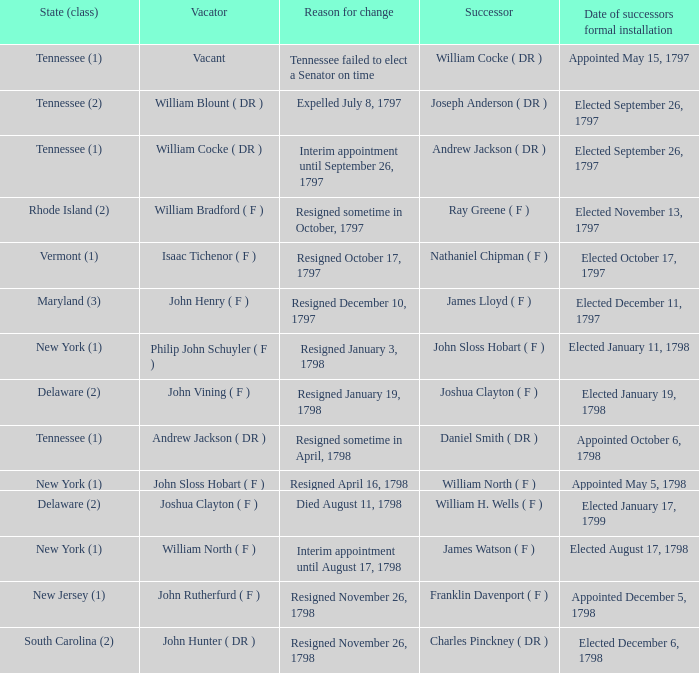During joseph anderson's (dr) succession, what were the different states (class)? Tennessee (2). 